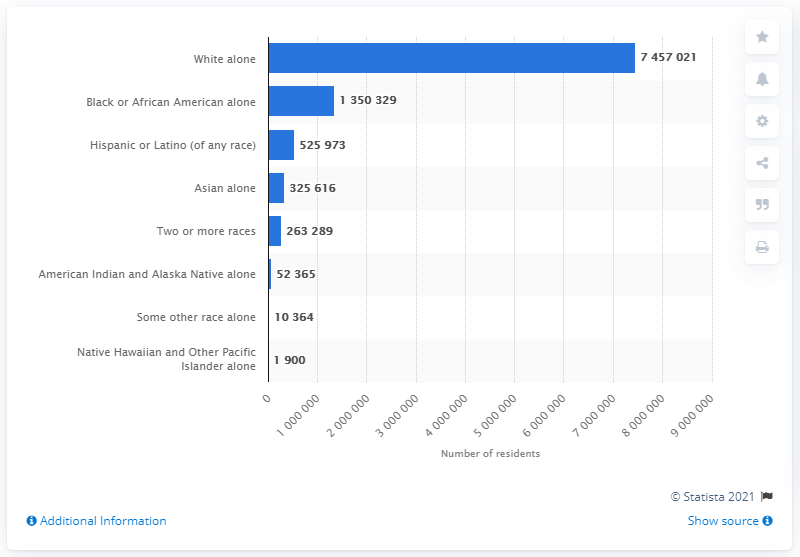Specify some key components in this picture. In 2019, there were approximately 135,032 black or African Americans living in the state of Michigan. 